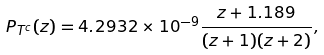<formula> <loc_0><loc_0><loc_500><loc_500>P _ { T ^ { c } } ( z ) = 4 . 2 9 3 2 \times 1 0 ^ { - 9 } \frac { z + 1 . 1 8 9 } { ( z + 1 ) ( z + 2 ) } ,</formula> 